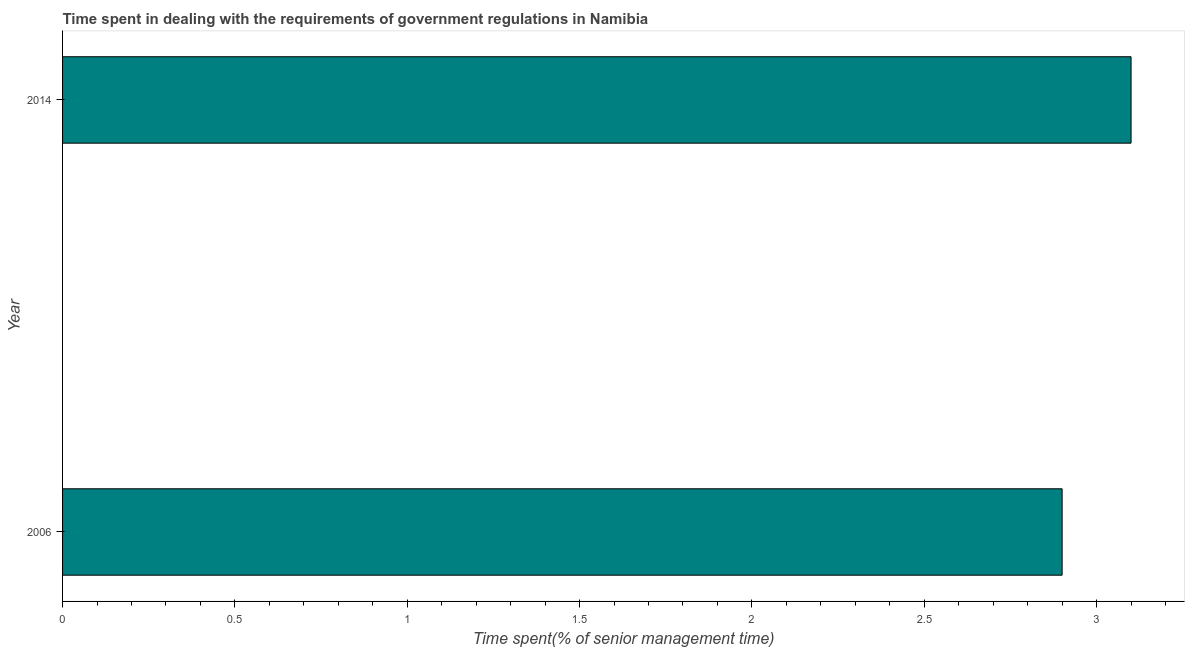What is the title of the graph?
Ensure brevity in your answer.  Time spent in dealing with the requirements of government regulations in Namibia. What is the label or title of the X-axis?
Ensure brevity in your answer.  Time spent(% of senior management time). What is the label or title of the Y-axis?
Keep it short and to the point. Year. What is the time spent in dealing with government regulations in 2006?
Offer a terse response. 2.9. Across all years, what is the maximum time spent in dealing with government regulations?
Your response must be concise. 3.1. Across all years, what is the minimum time spent in dealing with government regulations?
Give a very brief answer. 2.9. In which year was the time spent in dealing with government regulations minimum?
Keep it short and to the point. 2006. In how many years, is the time spent in dealing with government regulations greater than 0.7 %?
Offer a terse response. 2. Do a majority of the years between 2014 and 2006 (inclusive) have time spent in dealing with government regulations greater than 0.9 %?
Provide a short and direct response. No. What is the ratio of the time spent in dealing with government regulations in 2006 to that in 2014?
Ensure brevity in your answer.  0.94. Is the time spent in dealing with government regulations in 2006 less than that in 2014?
Your answer should be compact. Yes. In how many years, is the time spent in dealing with government regulations greater than the average time spent in dealing with government regulations taken over all years?
Your answer should be very brief. 1. How many bars are there?
Offer a very short reply. 2. Are all the bars in the graph horizontal?
Provide a succinct answer. Yes. How many years are there in the graph?
Provide a short and direct response. 2. What is the difference between two consecutive major ticks on the X-axis?
Provide a succinct answer. 0.5. What is the Time spent(% of senior management time) in 2014?
Your answer should be compact. 3.1. What is the ratio of the Time spent(% of senior management time) in 2006 to that in 2014?
Ensure brevity in your answer.  0.94. 